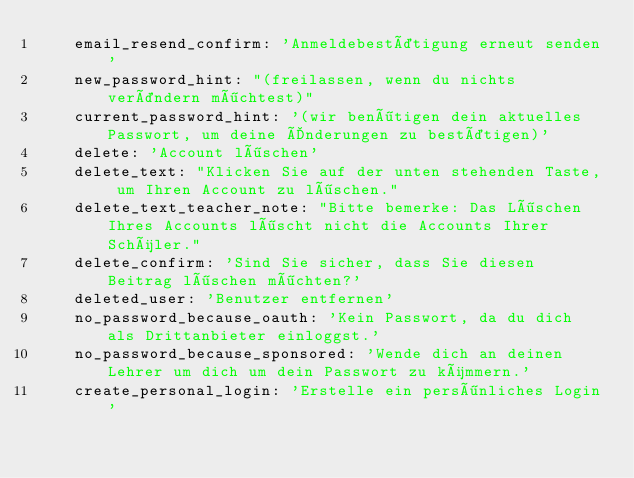Convert code to text. <code><loc_0><loc_0><loc_500><loc_500><_YAML_>    email_resend_confirm: 'Anmeldebestätigung erneut senden'
    new_password_hint: "(freilassen, wenn du nichts verändern möchtest)"
    current_password_hint: '(wir benötigen dein aktuelles Passwort, um deine Änderungen zu bestätigen)'
    delete: 'Account löschen'
    delete_text: "Klicken Sie auf der unten stehenden Taste, um Ihren Account zu löschen."
    delete_text_teacher_note: "Bitte bemerke: Das Löschen Ihres Accounts löscht nicht die Accounts Ihrer Schüler."
    delete_confirm: 'Sind Sie sicher, dass Sie diesen Beitrag löschen möchten?'
    deleted_user: 'Benutzer entfernen'
    no_password_because_oauth: 'Kein Passwort, da du dich als Drittanbieter einloggst.'
    no_password_because_sponsored: 'Wende dich an deinen Lehrer um dich um dein Passwort zu kümmern.'
    create_personal_login: 'Erstelle ein persönliches Login'</code> 